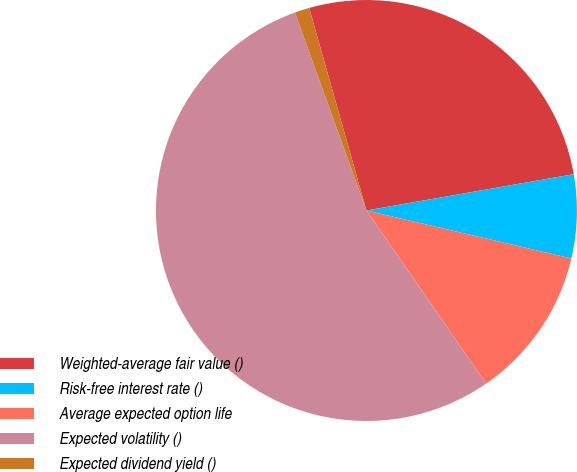Convert chart to OTSL. <chart><loc_0><loc_0><loc_500><loc_500><pie_chart><fcel>Weighted-average fair value ()<fcel>Risk-free interest rate ()<fcel>Average expected option life<fcel>Expected volatility ()<fcel>Expected dividend yield ()<nl><fcel>26.62%<fcel>6.42%<fcel>11.71%<fcel>54.11%<fcel>1.13%<nl></chart> 